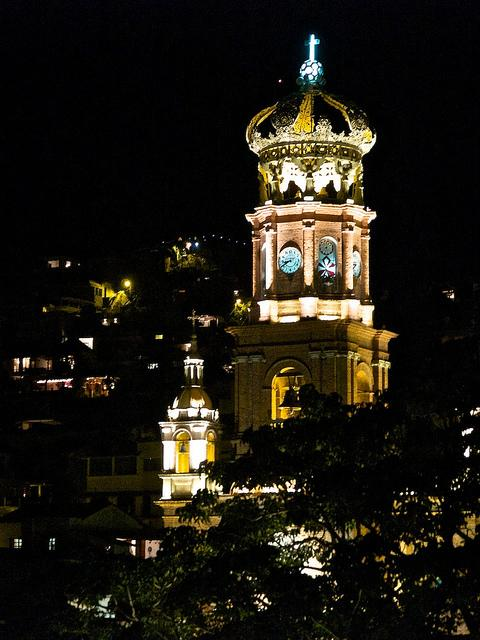What is on the top of the building? Please explain your reasoning. cross. There is a cross on the top of the building that is lit up. 